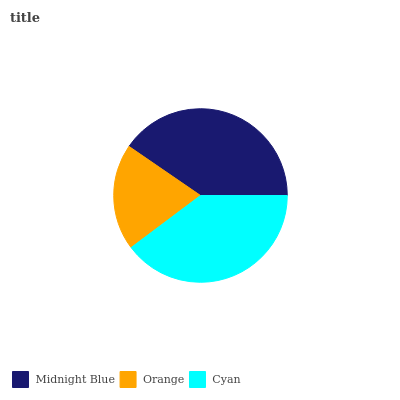Is Orange the minimum?
Answer yes or no. Yes. Is Midnight Blue the maximum?
Answer yes or no. Yes. Is Cyan the minimum?
Answer yes or no. No. Is Cyan the maximum?
Answer yes or no. No. Is Cyan greater than Orange?
Answer yes or no. Yes. Is Orange less than Cyan?
Answer yes or no. Yes. Is Orange greater than Cyan?
Answer yes or no. No. Is Cyan less than Orange?
Answer yes or no. No. Is Cyan the high median?
Answer yes or no. Yes. Is Cyan the low median?
Answer yes or no. Yes. Is Orange the high median?
Answer yes or no. No. Is Orange the low median?
Answer yes or no. No. 